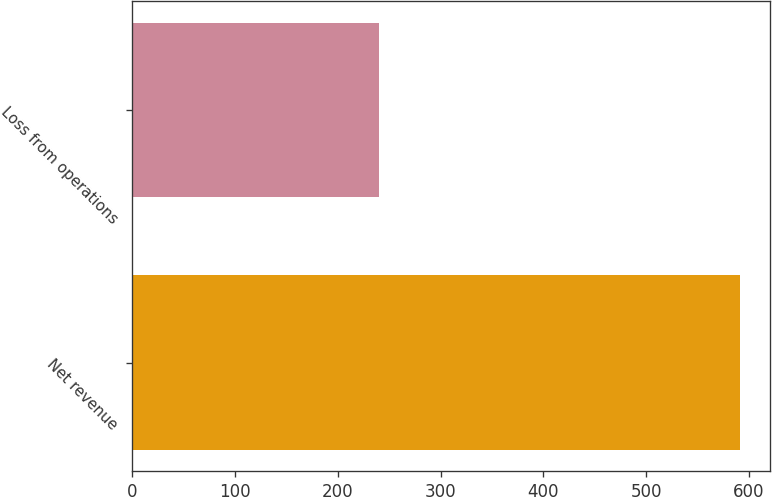<chart> <loc_0><loc_0><loc_500><loc_500><bar_chart><fcel>Net revenue<fcel>Loss from operations<nl><fcel>591<fcel>240<nl></chart> 